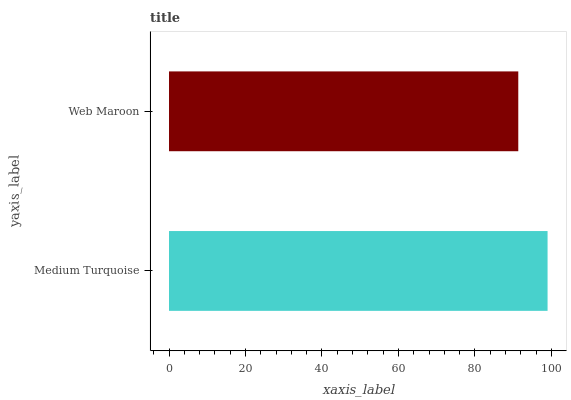Is Web Maroon the minimum?
Answer yes or no. Yes. Is Medium Turquoise the maximum?
Answer yes or no. Yes. Is Web Maroon the maximum?
Answer yes or no. No. Is Medium Turquoise greater than Web Maroon?
Answer yes or no. Yes. Is Web Maroon less than Medium Turquoise?
Answer yes or no. Yes. Is Web Maroon greater than Medium Turquoise?
Answer yes or no. No. Is Medium Turquoise less than Web Maroon?
Answer yes or no. No. Is Medium Turquoise the high median?
Answer yes or no. Yes. Is Web Maroon the low median?
Answer yes or no. Yes. Is Web Maroon the high median?
Answer yes or no. No. Is Medium Turquoise the low median?
Answer yes or no. No. 